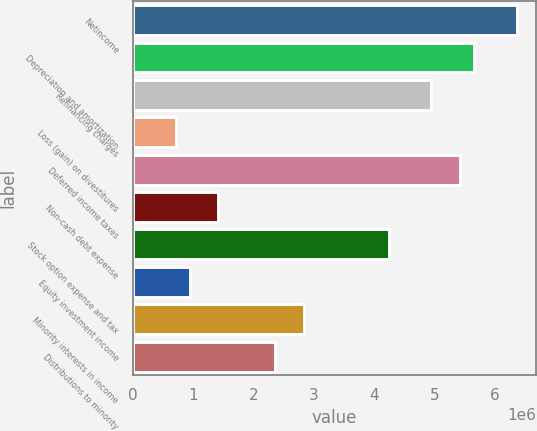Convert chart to OTSL. <chart><loc_0><loc_0><loc_500><loc_500><bar_chart><fcel>Netincome<fcel>Depreciation and amortization<fcel>Refinancing charges<fcel>Loss (gain) on divestitures<fcel>Deferred income taxes<fcel>Non-cash debt expense<fcel>Stock option expense and tax<fcel>Equity investment income<fcel>Minority interests in income<fcel>Distributions to minority<nl><fcel>6.3555e+06<fcel>5.64937e+06<fcel>4.94324e+06<fcel>706471<fcel>5.414e+06<fcel>1.4126e+06<fcel>4.23712e+06<fcel>941847<fcel>2.82486e+06<fcel>2.3541e+06<nl></chart> 